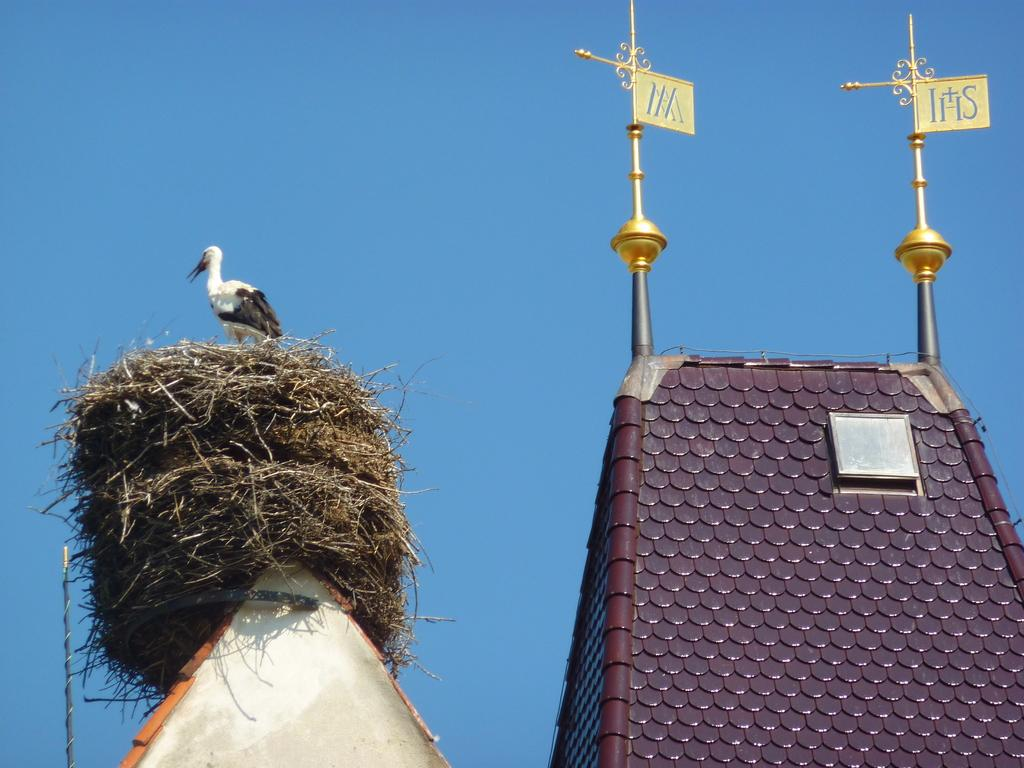What type of animal can be seen in the image? There is a bird in the image. Where is the bird located? The bird is standing on a nest. What is the nest resting on? The nest is on a house. What can be seen on the right side of the image? There is a house with metal rods on the right side of the image. What are the metal rods supporting? Boards are attached to the metal rods. What is visible in the background of the image? The sky is visible in the background of the image. What type of teeth can be seen in the image? There are no teeth visible in the image. 